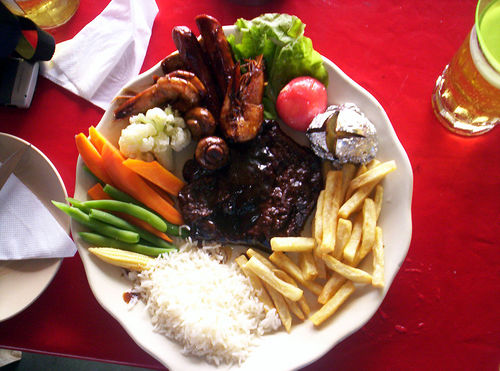<image>
Is the fries under the tomato? No. The fries is not positioned under the tomato. The vertical relationship between these objects is different. 